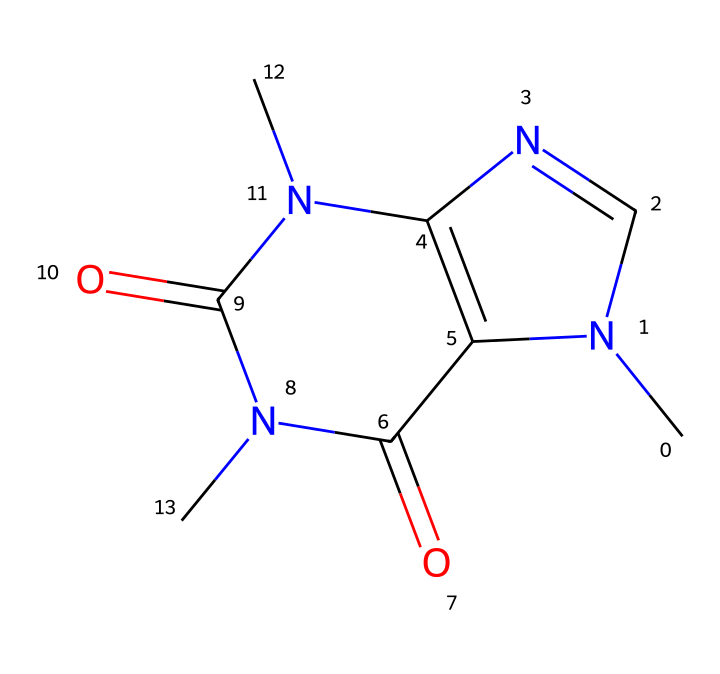what is the name of this chemical? The SMILES representation corresponds to caffeine, which is a well-known stimulant and a common component in beverages like coffee and tea. The structure can be identified through its specific arrangement of nitrogen, carbon, and oxygen atoms characteristic of caffeine.
Answer: caffeine how many nitrogen atoms are present in this structure? By examining the SMILES representation, we can count the nitrogen (N) atoms; there are four nitrogen atoms in the caffeine structure based on its molecular formula and arrangement.
Answer: four how many total carbon atoms are in the caffeine molecule? In the molecular structure of caffeine, there are 8 carbon atoms present as counted systematically from the SMILES representation. The carbon atoms are integral to the overall backbone of the molecule.
Answer: eight what type of functional groups does caffeine contain? Caffeine contains several functional groups, most notably amine (due to the presence of nitrogen) and carbonyl groups (due to the carbonyl oxygens). This combination contributes to its properties as a stimulant.
Answer: amine, carbonyl what effect does caffeine have on the central nervous system? Caffeine acts as a central nervous stimulant by blocking the effects of adenosine, which promotes sleep, thereby leading to increased alertness and reduced fatigue. This mechanism is important in occupational settings where fatigue might be an issue.
Answer: stimulation is caffeine considered a toxic chemical? Caffeine can be toxic in high amounts, leading to symptoms such as insomnia, nervousness, and increased heart rate, particularly when consumed excessively. Therefore, it is often categorized as a toxic chemical in high doses.
Answer: yes 